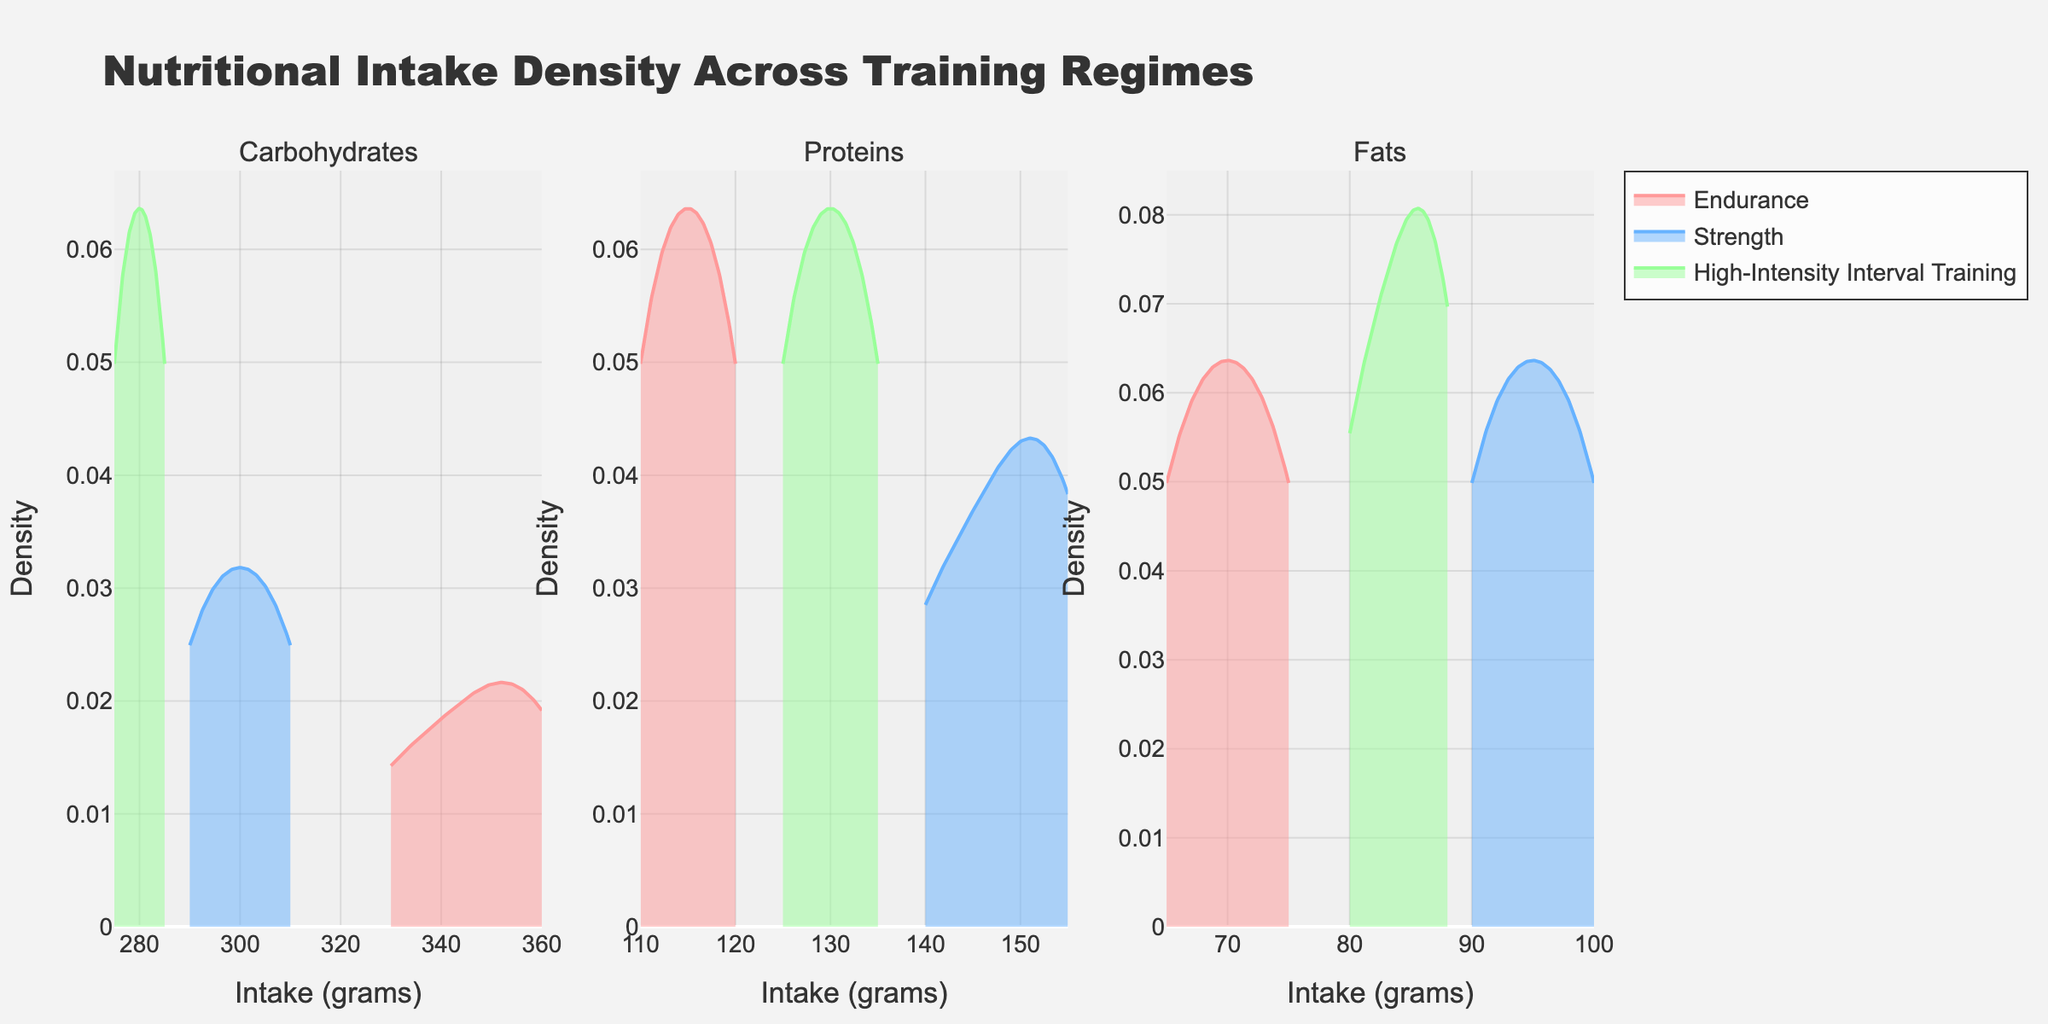What does the title of the plot say? The title is located at the top of the figure, which provides an overall description of the plot. It helps the viewer understand what the plot is about before examining the details.
Answer: Nutritional Intake Density Across Training Regimes What nutrients are being compared in the figure? The subplot titles above each of the three density plots specify which nutrients are being compared. These titles indicate the distinct elements being analyzed.
Answer: Carbohydrates, Proteins, Fats Which training regime has the highest density peak for protein intake? By examining the density curves in the second subplot (Proteins), we can observe and compare the highest points on the vertical axis. The training regime associated with the highest peak indicates the highest density.
Answer: Strength Between the Endurance and Strength training regimes, which one shows a broader range of intake for fats? By comparing the width of the density plots for "Endurance" and "Strength" in the third subplot (Fats), we can determine which regime has a broader range of intake values. The broader the curve, the wider the range.
Answer: Strength What intake range has the highest density for carbohydrates in High-Intensity Interval Training? By looking at the first subplot (Carbohydrates) and focusing on the High-Intensity Interval Training curve, we identify the intake range where the density reaches its peak. The X-axis values at this peak represent the range.
Answer: Around 270-300 grams Which training regime shows the most overlap with others for protein intake? In the second subplot (Proteins), analyzing the extent to which the density curves of different training regimes overlap will help us determine the regime with the most overlap.
Answer: High-Intensity Interval Training What is the color associated with the Strength training regime? The color used for each training regime helps to distinguish between them in the density plots. The legend on the plot shows the corresponding color for each regime.
Answer: Blue Does the density plot for fat intake under Endurance training show a single peak or multiple peaks? Observing the shape of the Endurance density curve in the third subplot (Fats) will allow us to determine if there's one main peak (unimodal) or more than one peak (multimodal).
Answer: Single peak For which nutrient does James have the highest intake in the High-Intensity Interval Training regime? By referring to the values in the High-Intensity Interval Training regime for James and comparing the intake values for each nutrient, we can identify which nutrient intake is the highest.
Answer: Carbohydrates 